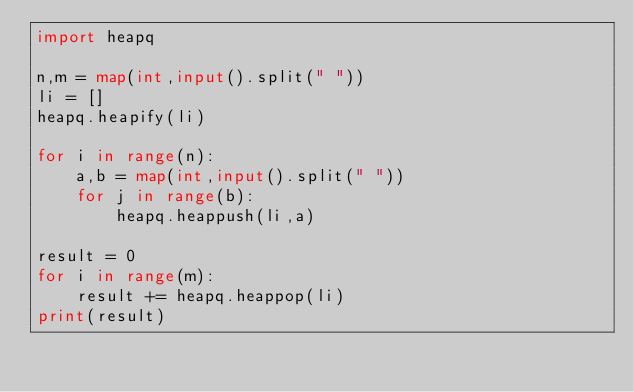<code> <loc_0><loc_0><loc_500><loc_500><_Python_>import heapq

n,m = map(int,input().split(" "))
li = []
heapq.heapify(li)

for i in range(n):
    a,b = map(int,input().split(" "))
    for j in range(b):
        heapq.heappush(li,a)

result = 0
for i in range(m):
    result += heapq.heappop(li)
print(result)</code> 